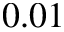<formula> <loc_0><loc_0><loc_500><loc_500>0 . 0 1</formula> 